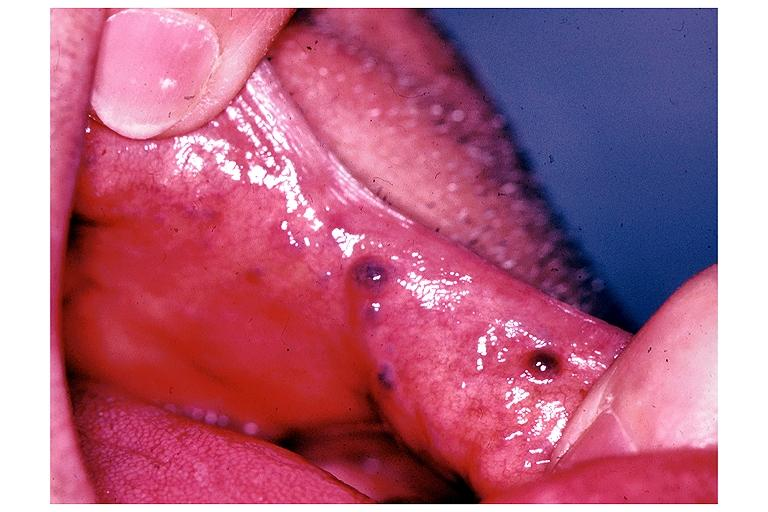what is present?
Answer the question using a single word or phrase. Oral 